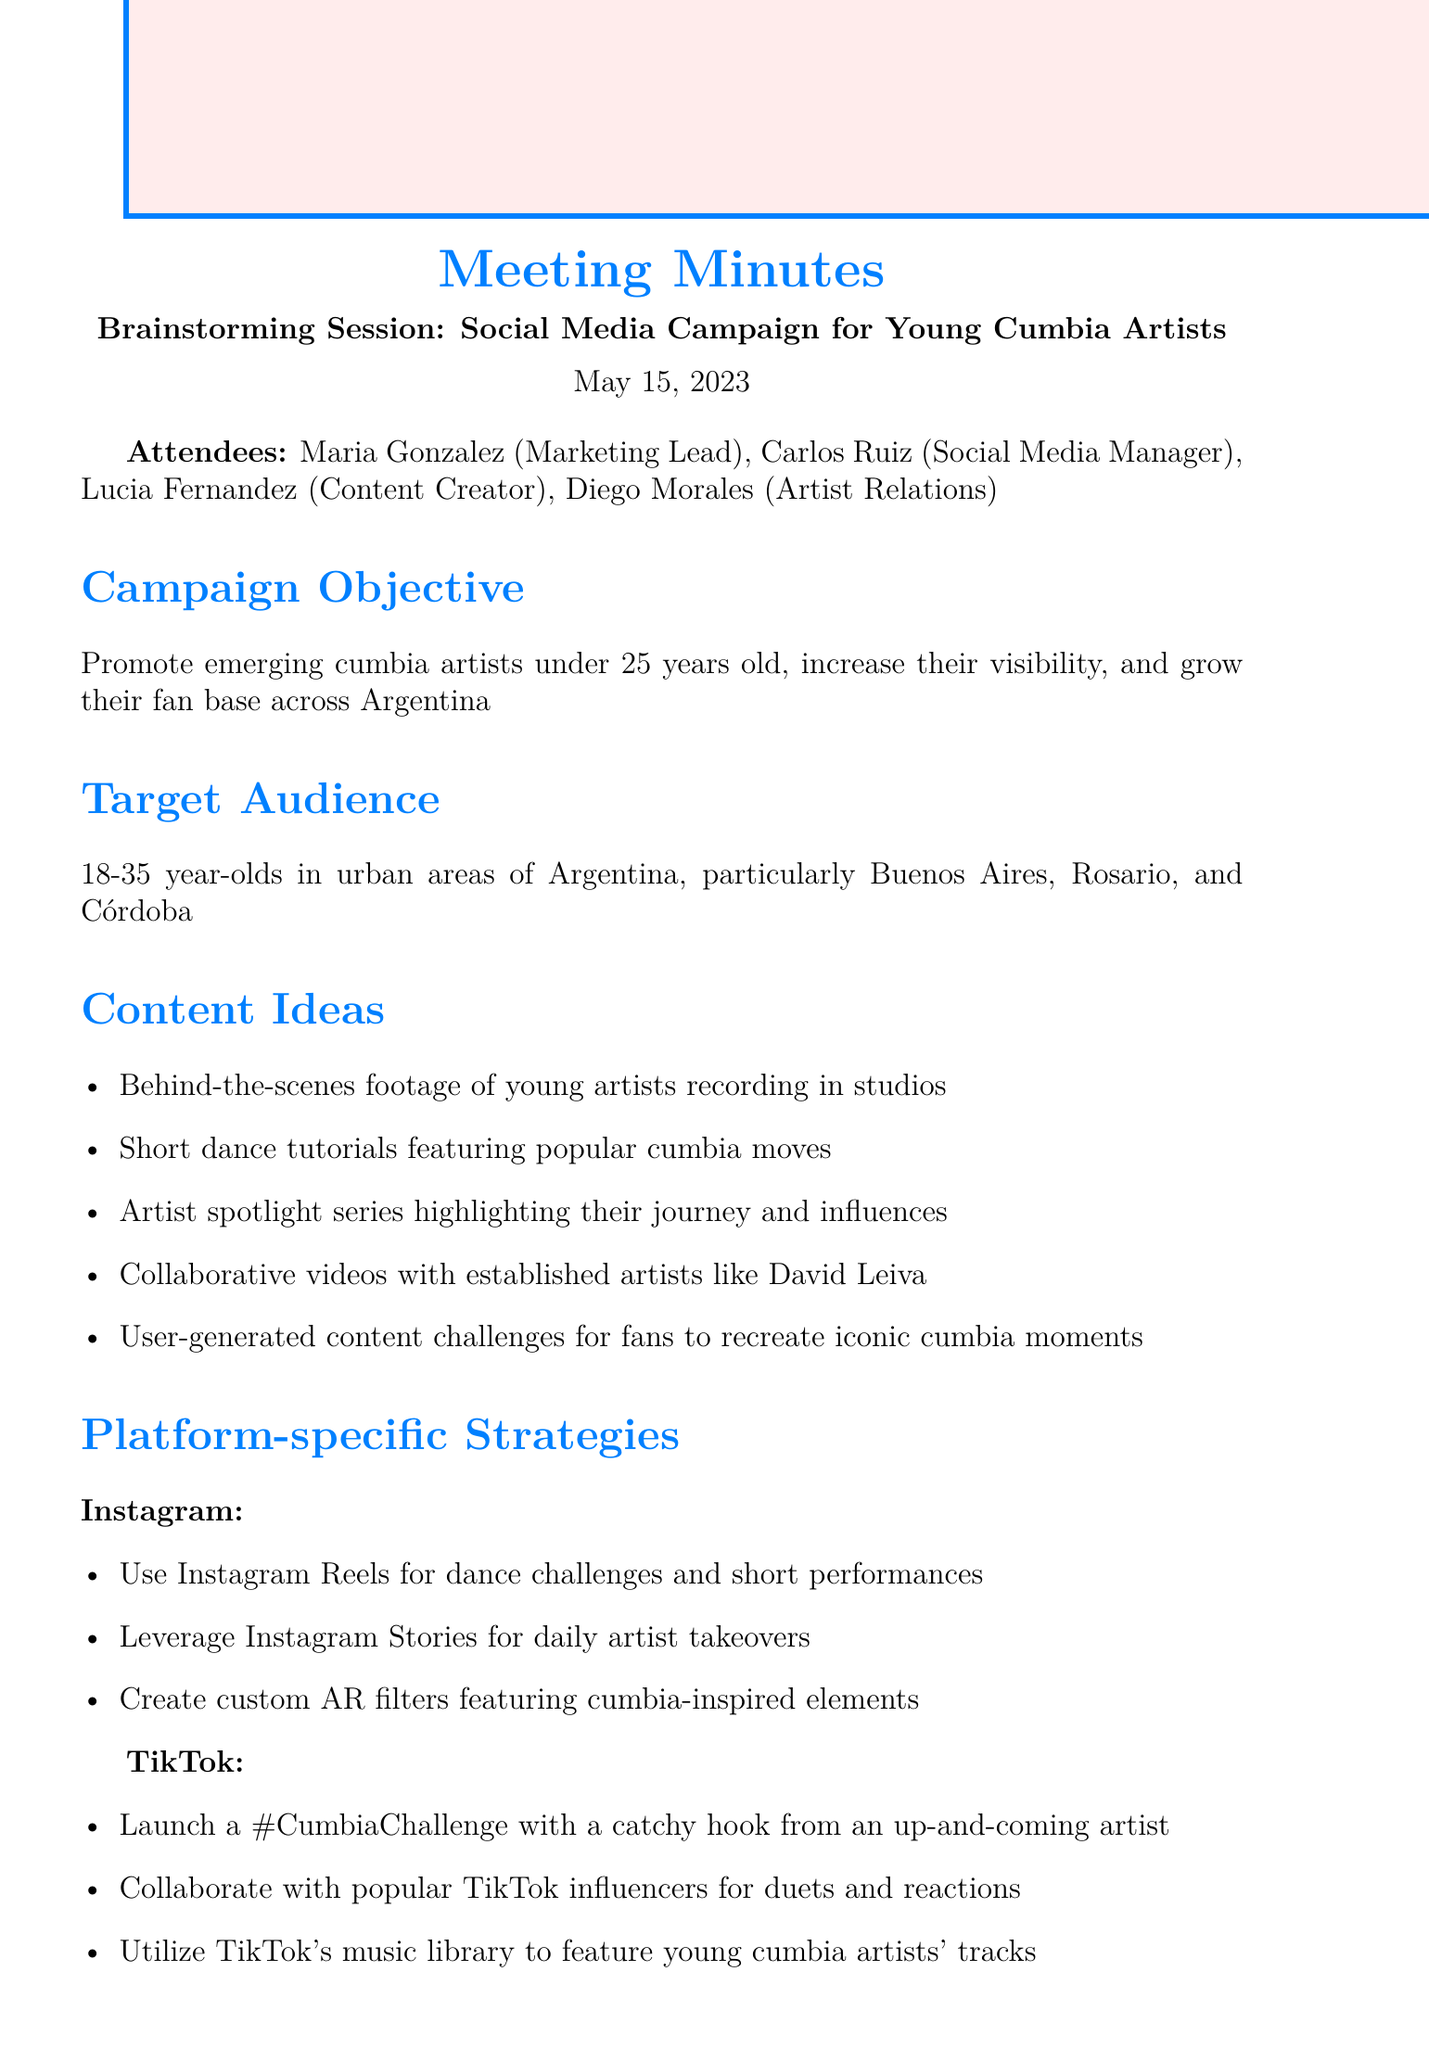What is the date of the meeting? The date of the meeting is mentioned in the document under the title.
Answer: May 15, 2023 Who is the Marketing Lead? The document lists attendees, including their roles, which indicates who the Marketing Lead is.
Answer: Maria Gonzalez What is the target audience age range? The target audience is specified in the agenda item about the target audience.
Answer: 18-35 year-olds What platform is mentioned for launching a dance challenge? The platform-specific strategies section describes tactics for various platforms, including where to launch a challenge.
Answer: TikTok Which artist is suggested for collaborative videos? The content ideas section includes mentions of collaborative content involving established artists.
Answer: David Leiva What are the key performance indicators related to? The key performance indicators describe metrics to evaluate the campaign success based on certain criteria.
Answer: Engagement rates How many potential partnerships are listed? The potential partnerships section contains a list and indicates how many partnerships are identified.
Answer: Three What is the objective of the campaign? The campaign objective is stated clearly at the beginning of the agenda items, outlining its purpose.
Answer: Promote emerging cumbia artists under 25 years old What is the next step regarding the young cumbia artists? The next steps are outlined to guide follow-up actions, pointing to what needs to be done for artists.
Answer: Finalize list of young cumbia artists to feature 